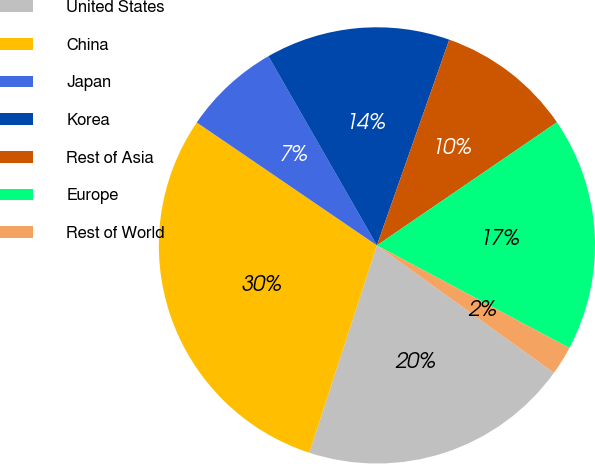<chart> <loc_0><loc_0><loc_500><loc_500><pie_chart><fcel>United States<fcel>China<fcel>Japan<fcel>Korea<fcel>Rest of Asia<fcel>Europe<fcel>Rest of World<nl><fcel>20.08%<fcel>29.51%<fcel>7.18%<fcel>13.67%<fcel>10.07%<fcel>17.34%<fcel>2.14%<nl></chart> 